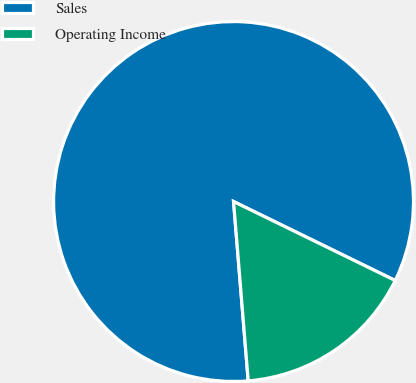Convert chart. <chart><loc_0><loc_0><loc_500><loc_500><pie_chart><fcel>Sales<fcel>Operating Income<nl><fcel>83.53%<fcel>16.47%<nl></chart> 